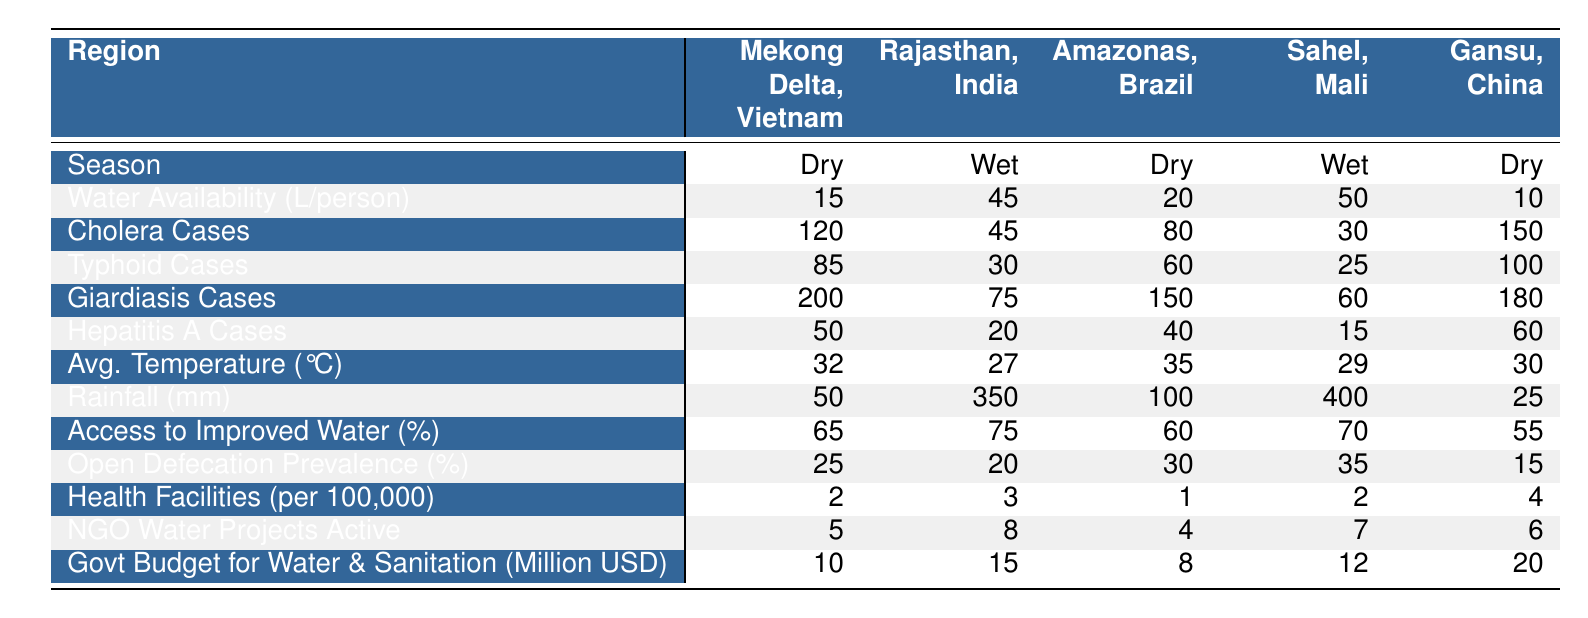What is the water availability per person in Rajasthan during the wet season? The table shows that the water availability in Rajasthan during the wet season is 45 liters per person.
Answer: 45 liters How many cholera cases were reported in the Mekong Delta, Vietnam during the dry season? According to the table, there were 120 cholera cases reported in the Mekong Delta, Vietnam during the dry season.
Answer: 120 cases What is the average number of Giardiasis cases across all regions during the dry season? The most notable information from the table: Giardiasis cases in dry season regions are 200 (Mekong Delta) + 150 (Amazonas) + 180 (Gansu) = 530. 
Since there are three regions reporting for dry season, the average is 530 / 3 = 176.67, but rounding indicates an average of 177.
Answer: 177 cases Is there a higher percentage of access to improved water sources in the Mekong Delta or Gansu? The table indicates that access to improved water sources in the Mekong Delta is 65% while in Gansu it is 55%. Thus, the Mekong Delta has a higher percentage.
Answer: Yes What is the difference in the average rainfall between the wet season in Rajasthan and the wet season in Sahel? The average rainfall in Rajasthan during the wet season is 350 mm, and in Sahel, it is 400 mm. The difference is 400 - 350 = 50 mm.
Answer: 50 mm In which region is the prevalence of open defecation lowest, and what is that percentage? The table shows the prevalence of open defecation is lowest in Gansu at 15%.
Answer: Gansu, 15% How many more typhoid cases were reported in the Mekong Delta compared to Sahel? The table reports 85 typhoid cases in the Mekong Delta and 25 cases in Sahel. The difference is 85 - 25 = 60 cases more in the Mekong Delta.
Answer: 60 cases Which region has the highest government budget for water and sanitation, and how much is it? Gansu has the highest government budget for water and sanitation at 20 million USD.
Answer: Gansu, 20 million USD If you combine the cholera cases from Amazonas and Sahel, how many total cases are there? The table shows cholera cases are 80 in Amazonas and 30 in Sahel. Adding these gives 80 + 30 = 110 total cases.
Answer: 110 cases What is the average temperature during the dry season across all regions? The average temperatures in the dry season regions are 32°C (Mekong Delta) + 35°C (Amazonas) + 30°C (Gansu) = 97°C. Dividing by 3 gives an average of 32.33°C, which rounds to 32°C.
Answer: 32°C 